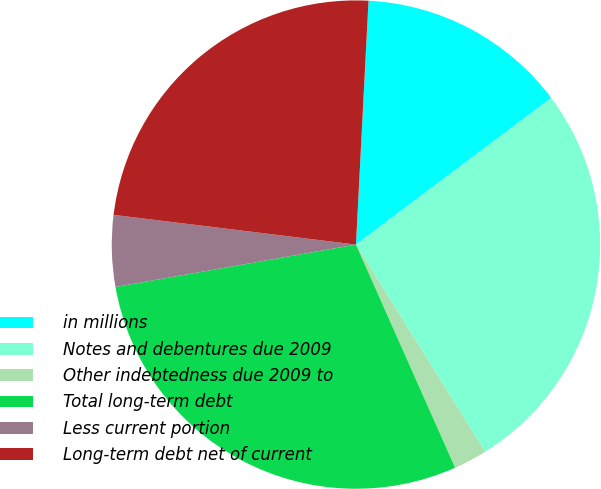Convert chart to OTSL. <chart><loc_0><loc_0><loc_500><loc_500><pie_chart><fcel>in millions<fcel>Notes and debentures due 2009<fcel>Other indebtedness due 2009 to<fcel>Total long-term debt<fcel>Less current portion<fcel>Long-term debt net of current<nl><fcel>13.93%<fcel>26.38%<fcel>2.22%<fcel>28.88%<fcel>4.72%<fcel>23.88%<nl></chart> 